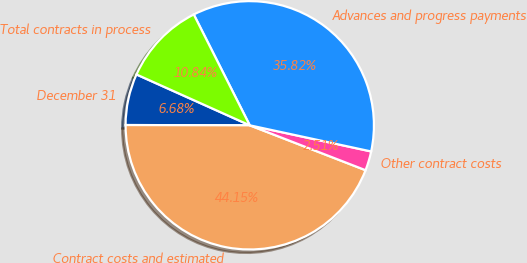<chart> <loc_0><loc_0><loc_500><loc_500><pie_chart><fcel>December 31<fcel>Contract costs and estimated<fcel>Other contract costs<fcel>Advances and progress payments<fcel>Total contracts in process<nl><fcel>6.68%<fcel>44.15%<fcel>2.51%<fcel>35.82%<fcel>10.84%<nl></chart> 